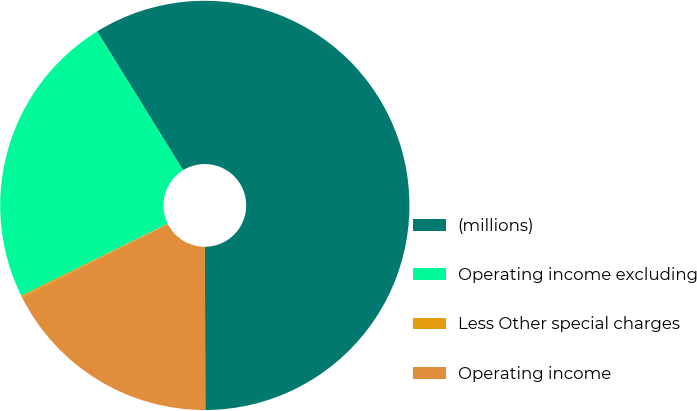Convert chart. <chart><loc_0><loc_0><loc_500><loc_500><pie_chart><fcel>(millions)<fcel>Operating income excluding<fcel>Less Other special charges<fcel>Operating income<nl><fcel>58.78%<fcel>23.46%<fcel>0.15%<fcel>17.6%<nl></chart> 